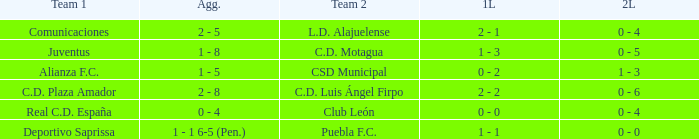What is the 1st leg where Team 1 is C.D. Plaza Amador? 2 - 2. 